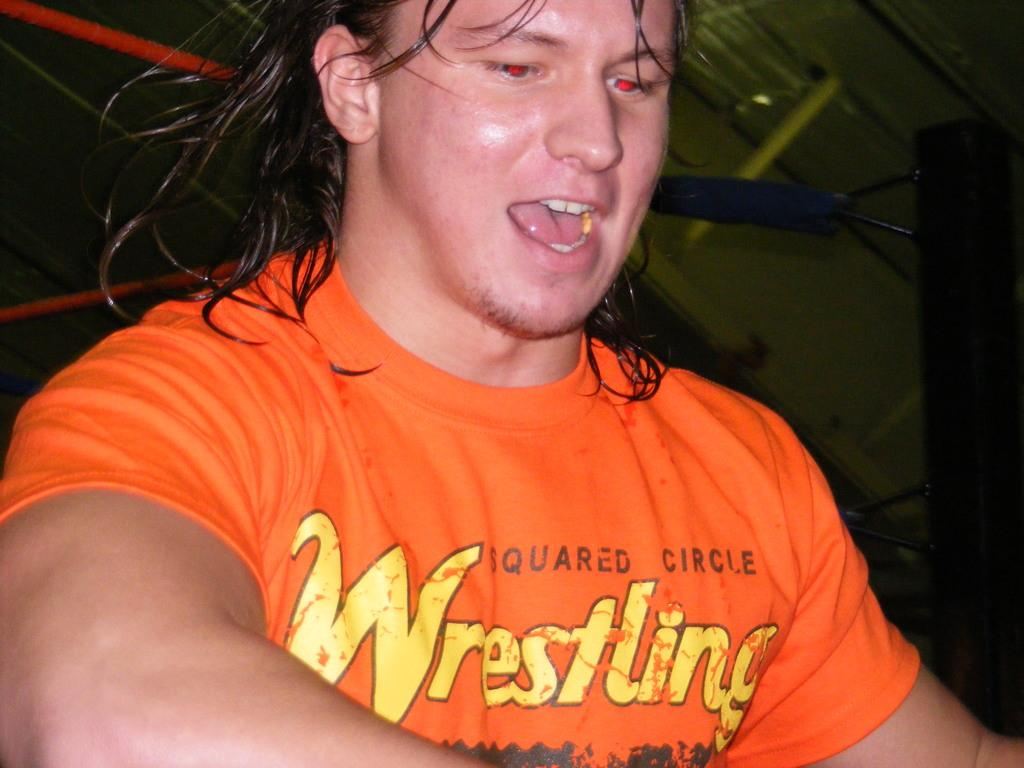What is the main subject in the image? There is a man standing in the image. What is located behind the man? There is a fencing behind the man. What can be seen at the top of the image? The top of the image contains a roof. What type of form is the man filling out in the lunchroom during this minute? There is no form, lunchroom, or indication of time in the image; it only shows a man standing with a fencing behind him and a roof at the top. 